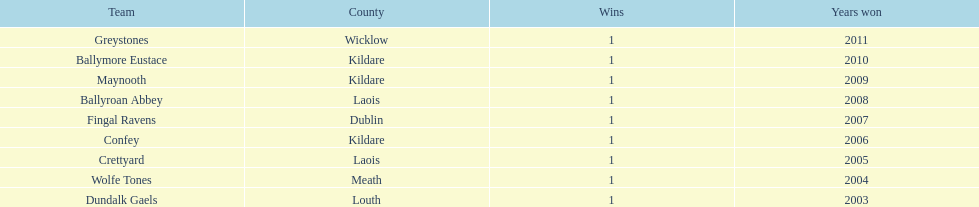What are the winning years for each team? 2011, 2010, 2009, 2008, 2007, 2006, 2005, 2004, 2003. 